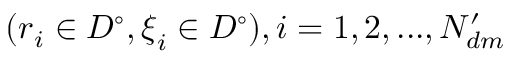Convert formula to latex. <formula><loc_0><loc_0><loc_500><loc_500>( r _ { i } \in D ^ { \circ } , \xi _ { i } \in D ^ { \circ } ) , i = 1 , 2 , \dots , N _ { d m } ^ { \prime }</formula> 